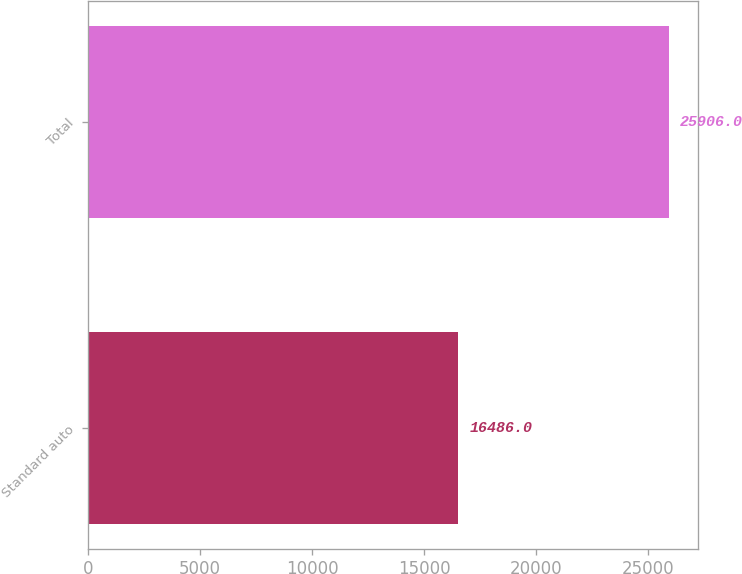<chart> <loc_0><loc_0><loc_500><loc_500><bar_chart><fcel>Standard auto<fcel>Total<nl><fcel>16486<fcel>25906<nl></chart> 